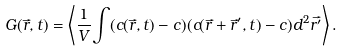<formula> <loc_0><loc_0><loc_500><loc_500>G ( \vec { r } , t ) = \left \langle \frac { 1 } { V } { \int } ( c ( \vec { r } , t ) - c ) ( c ( \vec { r } + \vec { r } ^ { \prime } , t ) - c ) d ^ { 2 } \vec { r ^ { \prime } } \right \rangle .</formula> 